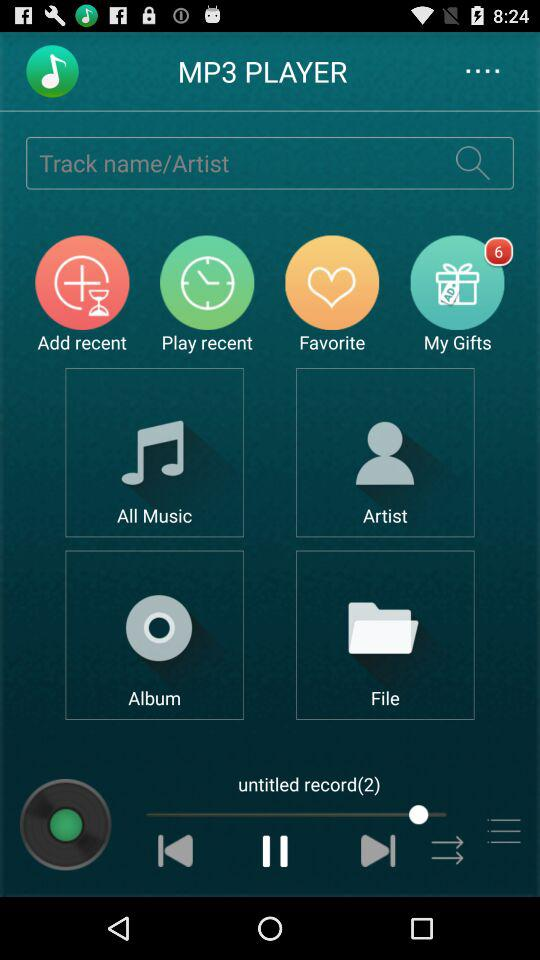What is the application name? The application name is "MP3 PLAYER". 